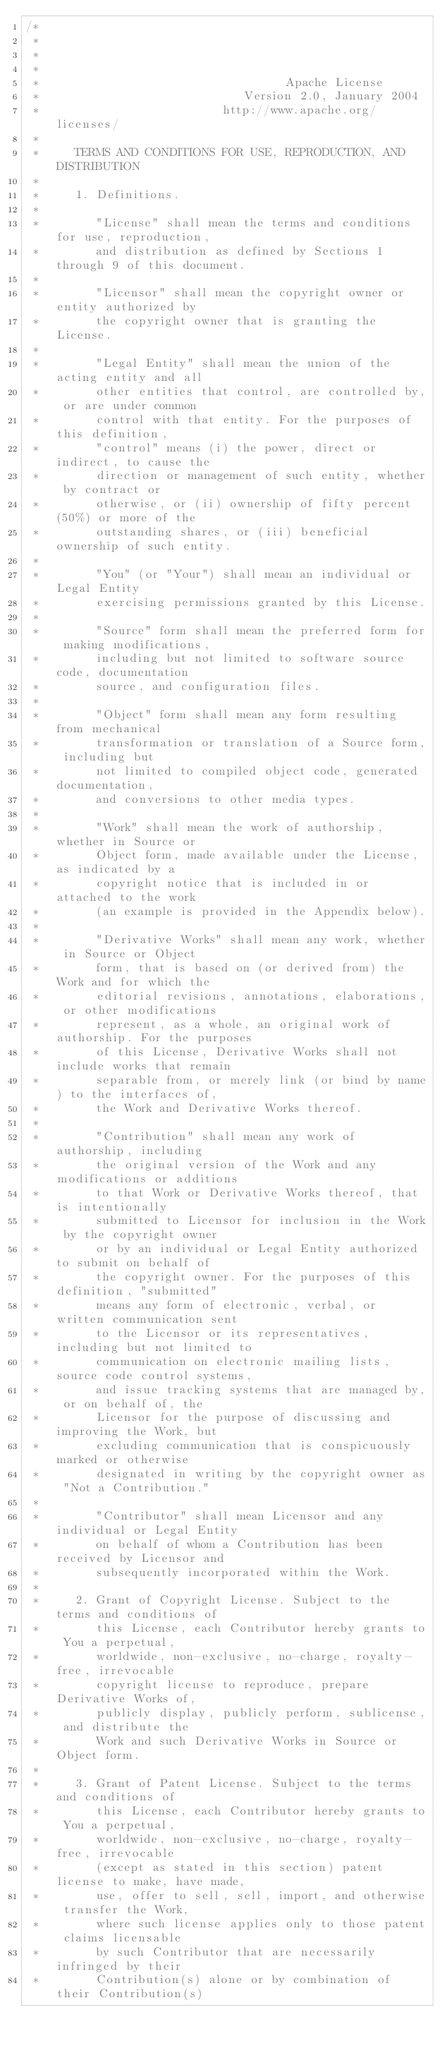<code> <loc_0><loc_0><loc_500><loc_500><_Java_>/*
 *
 *
 *
 *                                   Apache License
 *                             Version 2.0, January 2004
 *                          http://www.apache.org/licenses/
 *
 *     TERMS AND CONDITIONS FOR USE, REPRODUCTION, AND DISTRIBUTION
 *
 *     1. Definitions.
 *
 *        "License" shall mean the terms and conditions for use, reproduction,
 *        and distribution as defined by Sections 1 through 9 of this document.
 *
 *        "Licensor" shall mean the copyright owner or entity authorized by
 *        the copyright owner that is granting the License.
 *
 *        "Legal Entity" shall mean the union of the acting entity and all
 *        other entities that control, are controlled by, or are under common
 *        control with that entity. For the purposes of this definition,
 *        "control" means (i) the power, direct or indirect, to cause the
 *        direction or management of such entity, whether by contract or
 *        otherwise, or (ii) ownership of fifty percent (50%) or more of the
 *        outstanding shares, or (iii) beneficial ownership of such entity.
 *
 *        "You" (or "Your") shall mean an individual or Legal Entity
 *        exercising permissions granted by this License.
 *
 *        "Source" form shall mean the preferred form for making modifications,
 *        including but not limited to software source code, documentation
 *        source, and configuration files.
 *
 *        "Object" form shall mean any form resulting from mechanical
 *        transformation or translation of a Source form, including but
 *        not limited to compiled object code, generated documentation,
 *        and conversions to other media types.
 *
 *        "Work" shall mean the work of authorship, whether in Source or
 *        Object form, made available under the License, as indicated by a
 *        copyright notice that is included in or attached to the work
 *        (an example is provided in the Appendix below).
 *
 *        "Derivative Works" shall mean any work, whether in Source or Object
 *        form, that is based on (or derived from) the Work and for which the
 *        editorial revisions, annotations, elaborations, or other modifications
 *        represent, as a whole, an original work of authorship. For the purposes
 *        of this License, Derivative Works shall not include works that remain
 *        separable from, or merely link (or bind by name) to the interfaces of,
 *        the Work and Derivative Works thereof.
 *
 *        "Contribution" shall mean any work of authorship, including
 *        the original version of the Work and any modifications or additions
 *        to that Work or Derivative Works thereof, that is intentionally
 *        submitted to Licensor for inclusion in the Work by the copyright owner
 *        or by an individual or Legal Entity authorized to submit on behalf of
 *        the copyright owner. For the purposes of this definition, "submitted"
 *        means any form of electronic, verbal, or written communication sent
 *        to the Licensor or its representatives, including but not limited to
 *        communication on electronic mailing lists, source code control systems,
 *        and issue tracking systems that are managed by, or on behalf of, the
 *        Licensor for the purpose of discussing and improving the Work, but
 *        excluding communication that is conspicuously marked or otherwise
 *        designated in writing by the copyright owner as "Not a Contribution."
 *
 *        "Contributor" shall mean Licensor and any individual or Legal Entity
 *        on behalf of whom a Contribution has been received by Licensor and
 *        subsequently incorporated within the Work.
 *
 *     2. Grant of Copyright License. Subject to the terms and conditions of
 *        this License, each Contributor hereby grants to You a perpetual,
 *        worldwide, non-exclusive, no-charge, royalty-free, irrevocable
 *        copyright license to reproduce, prepare Derivative Works of,
 *        publicly display, publicly perform, sublicense, and distribute the
 *        Work and such Derivative Works in Source or Object form.
 *
 *     3. Grant of Patent License. Subject to the terms and conditions of
 *        this License, each Contributor hereby grants to You a perpetual,
 *        worldwide, non-exclusive, no-charge, royalty-free, irrevocable
 *        (except as stated in this section) patent license to make, have made,
 *        use, offer to sell, sell, import, and otherwise transfer the Work,
 *        where such license applies only to those patent claims licensable
 *        by such Contributor that are necessarily infringed by their
 *        Contribution(s) alone or by combination of their Contribution(s)</code> 